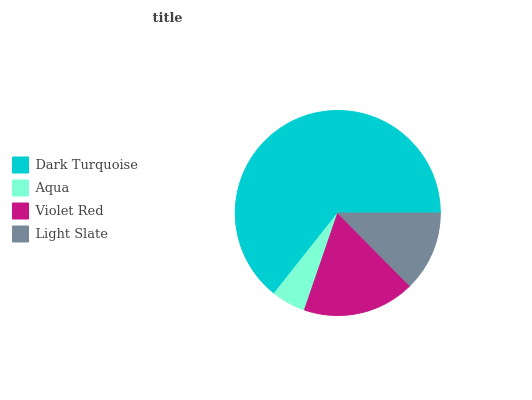Is Aqua the minimum?
Answer yes or no. Yes. Is Dark Turquoise the maximum?
Answer yes or no. Yes. Is Violet Red the minimum?
Answer yes or no. No. Is Violet Red the maximum?
Answer yes or no. No. Is Violet Red greater than Aqua?
Answer yes or no. Yes. Is Aqua less than Violet Red?
Answer yes or no. Yes. Is Aqua greater than Violet Red?
Answer yes or no. No. Is Violet Red less than Aqua?
Answer yes or no. No. Is Violet Red the high median?
Answer yes or no. Yes. Is Light Slate the low median?
Answer yes or no. Yes. Is Light Slate the high median?
Answer yes or no. No. Is Violet Red the low median?
Answer yes or no. No. 